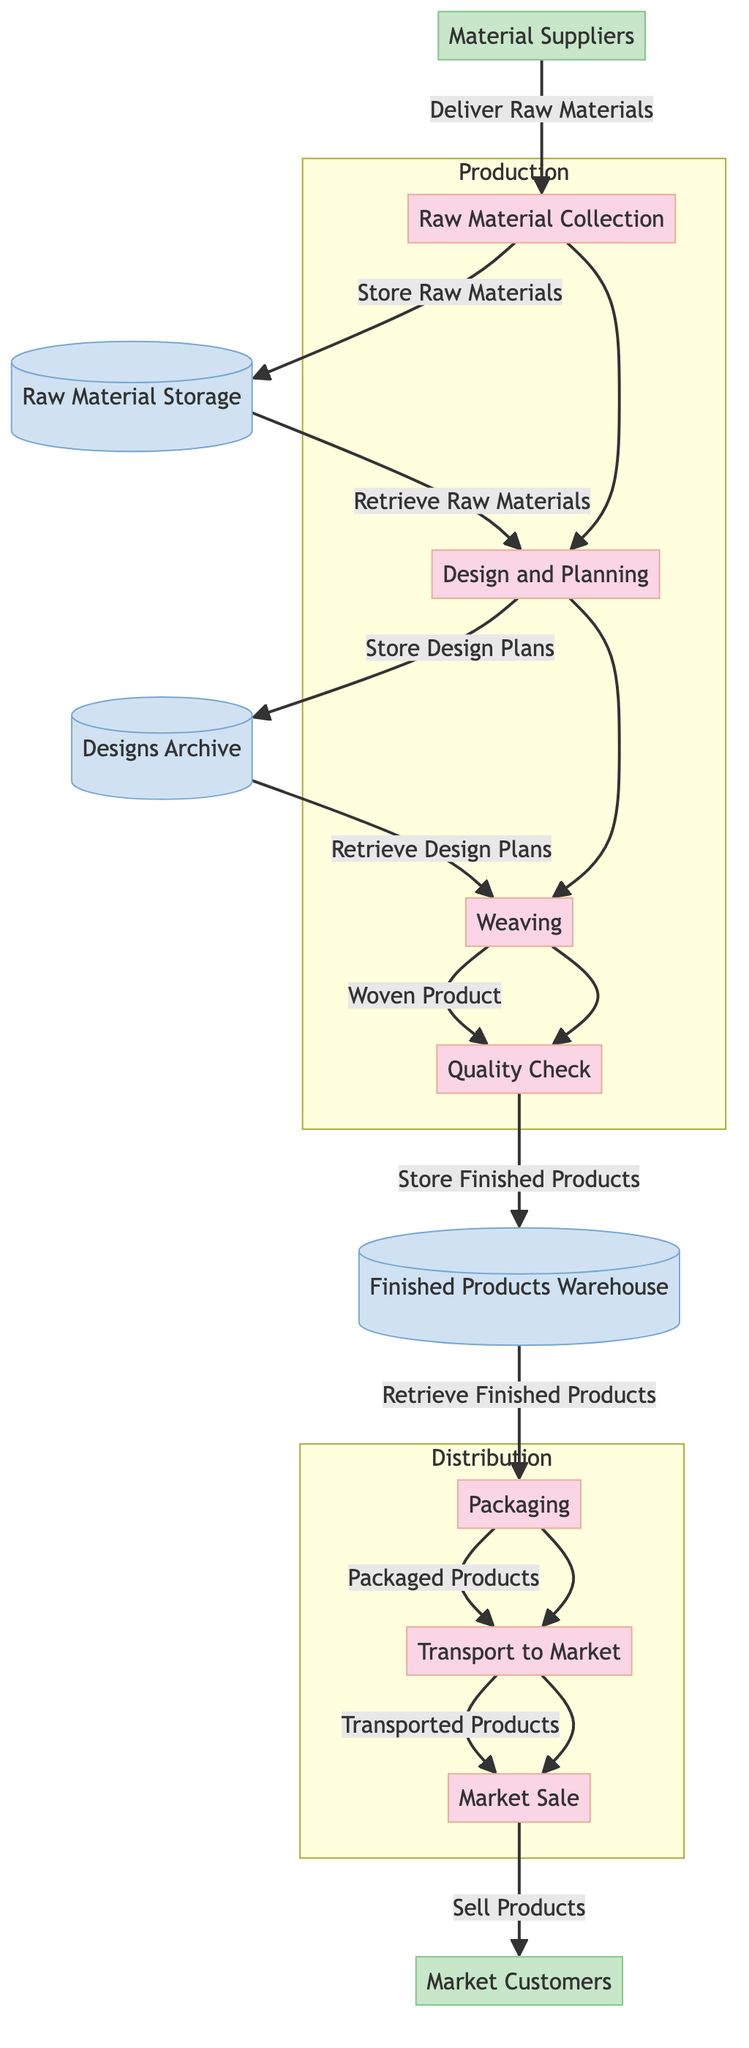What is the first process in the diagram? The first process listed in the diagram is "Raw Material Collection," which is where the flow begins as materials are delivered to this stage.
Answer: Raw Material Collection How many processes are in the diagram? The diagram includes a total of seven processes that reflect the journey of the woven product from its creation to the sale in the market.
Answer: 7 Which external entity provides materials? The diagram specifies "Material Suppliers" as the external entity responsible for delivering raw materials for the weaving process.
Answer: Material Suppliers What is the last process before market sale? The process that occurs immediately before "Market Sale" is "Transport to Market," indicating that products are transported just before they are sold.
Answer: Transport to Market How many data stores exist in the diagram? There are three data stores identified in the diagram, representing storage locations for raw materials, design plans, and finished products.
Answer: 3 What flow comes from the Quality Check process? The flow from the "Quality Check" process leads to storing finished products in the "Finished Products Warehouse," indicating that checked products are stored before packaging.
Answer: Store Finished Products Which process retrieves design plans? "Weaving" is the process that retrieves design plans from the "Designs Archive," indicating it needs these plans to create woven products.
Answer: Weaving What products are packaged? The products that are packaged are the finished woven products, which have been completed and passed quality checks before they are packaged for transport.
Answer: Packaged Products Which design storage is accessed after raw materials? The "Designs Archive" is accessed after retrieving raw materials, as design plans are necessary for the next steps in the weaving process.
Answer: Designs Archive 